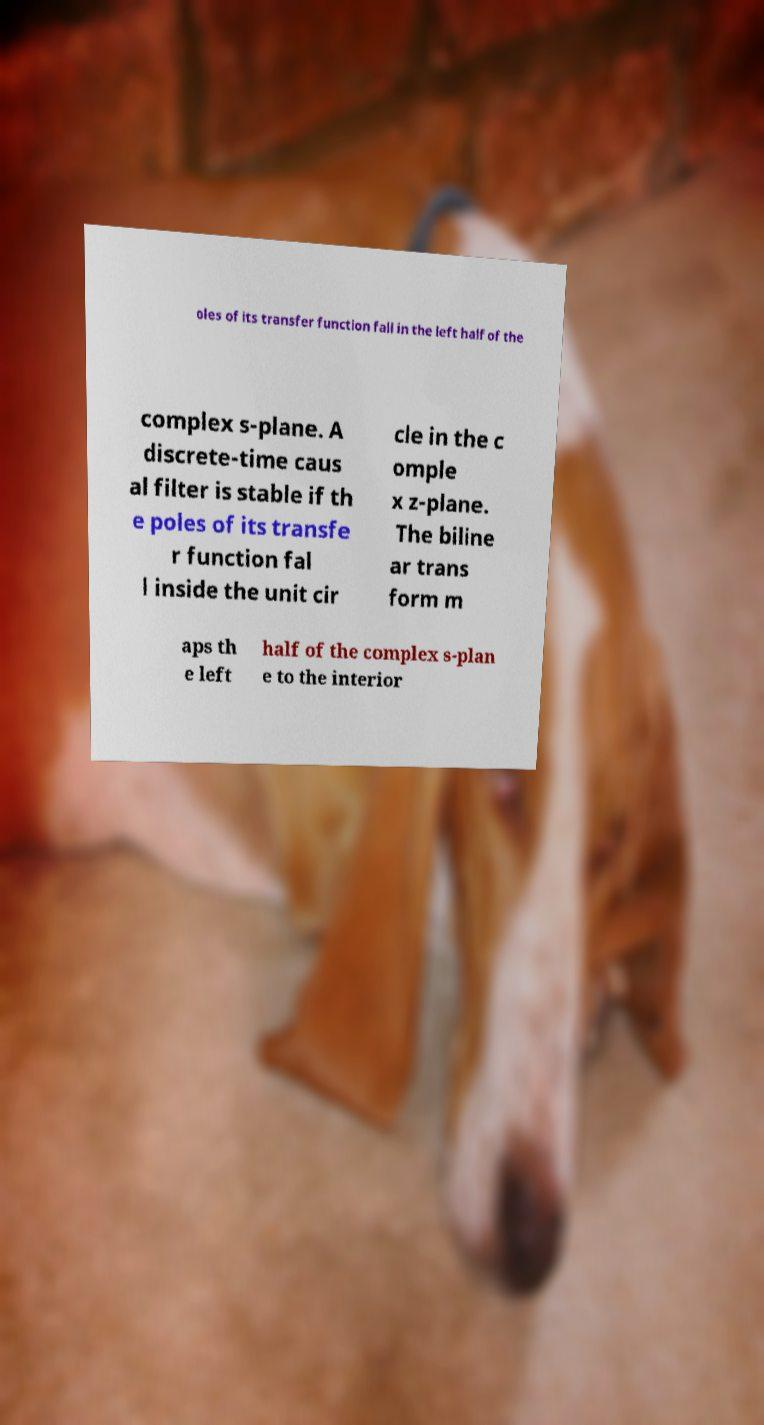Could you assist in decoding the text presented in this image and type it out clearly? oles of its transfer function fall in the left half of the complex s-plane. A discrete-time caus al filter is stable if th e poles of its transfe r function fal l inside the unit cir cle in the c omple x z-plane. The biline ar trans form m aps th e left half of the complex s-plan e to the interior 